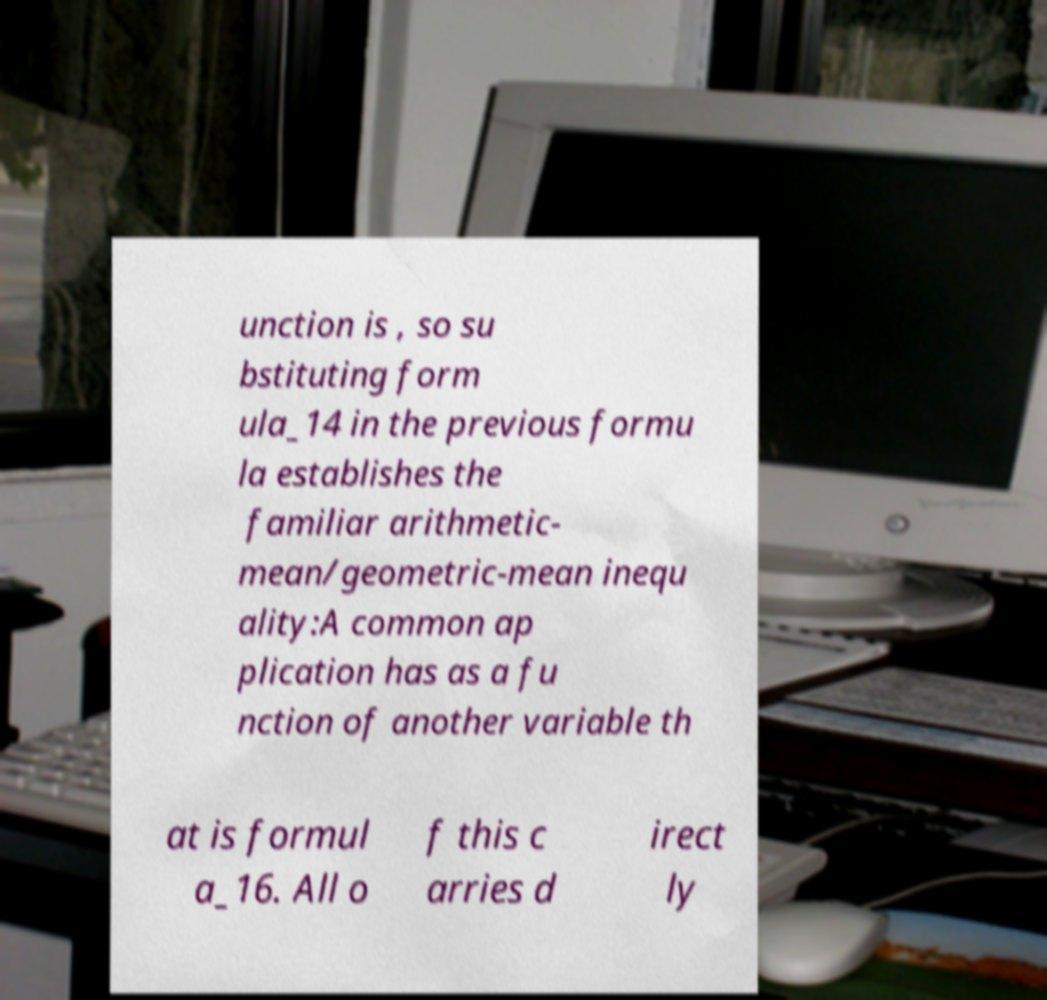Could you extract and type out the text from this image? unction is , so su bstituting form ula_14 in the previous formu la establishes the familiar arithmetic- mean/geometric-mean inequ ality:A common ap plication has as a fu nction of another variable th at is formul a_16. All o f this c arries d irect ly 